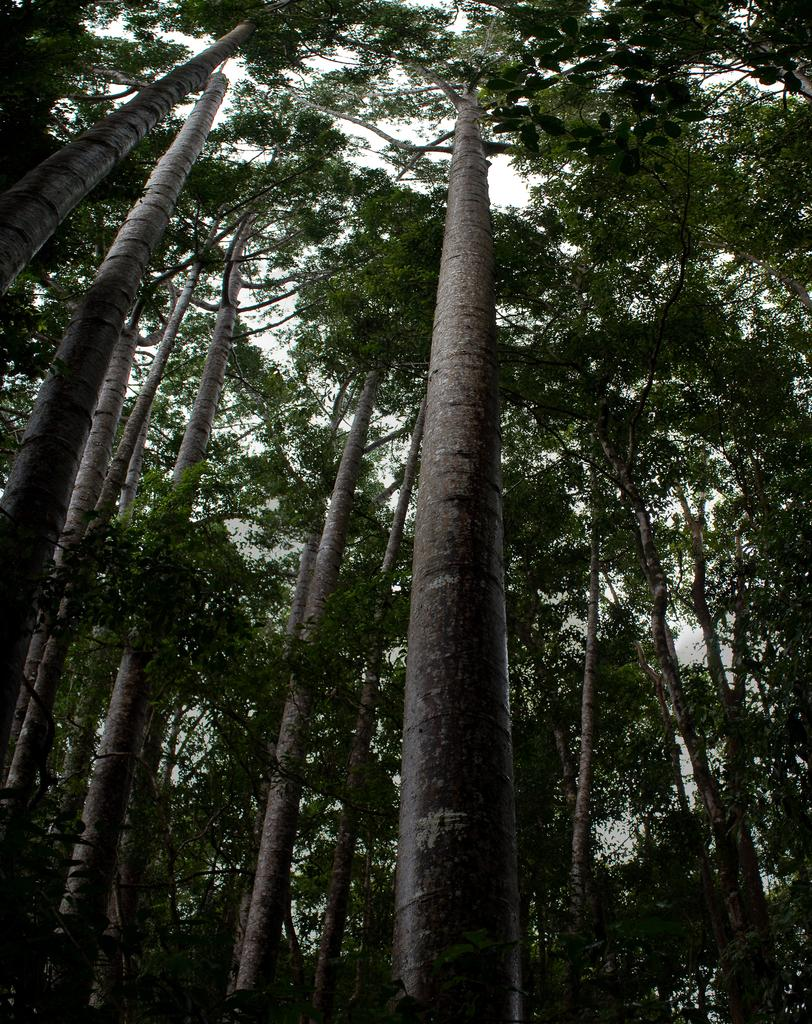What type of vegetation can be seen in the image? There are trees in the image. How tall are the trees in the image? The trees are very tall in height. Where is the drain located in the image? There is no drain present in the image. How much money is visible in the image? There is no money present in the image. What type of clothing is the person wearing in the image? There is no person present in the image, so it is not possible to determine what type of clothing they might be wearing. 